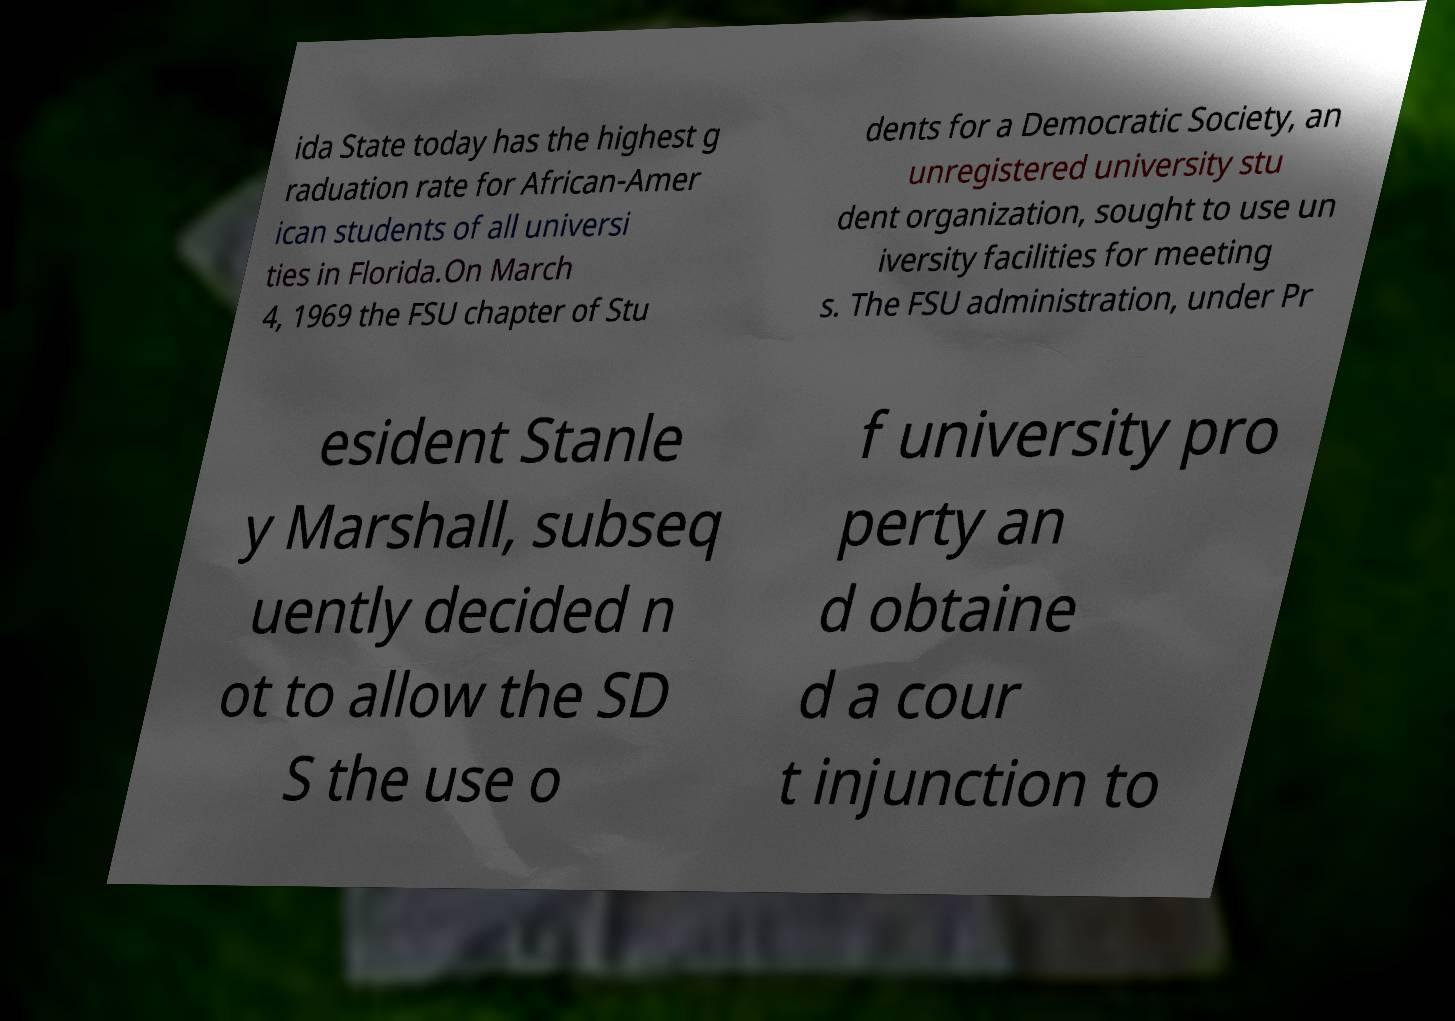Could you extract and type out the text from this image? ida State today has the highest g raduation rate for African-Amer ican students of all universi ties in Florida.On March 4, 1969 the FSU chapter of Stu dents for a Democratic Society, an unregistered university stu dent organization, sought to use un iversity facilities for meeting s. The FSU administration, under Pr esident Stanle y Marshall, subseq uently decided n ot to allow the SD S the use o f university pro perty an d obtaine d a cour t injunction to 